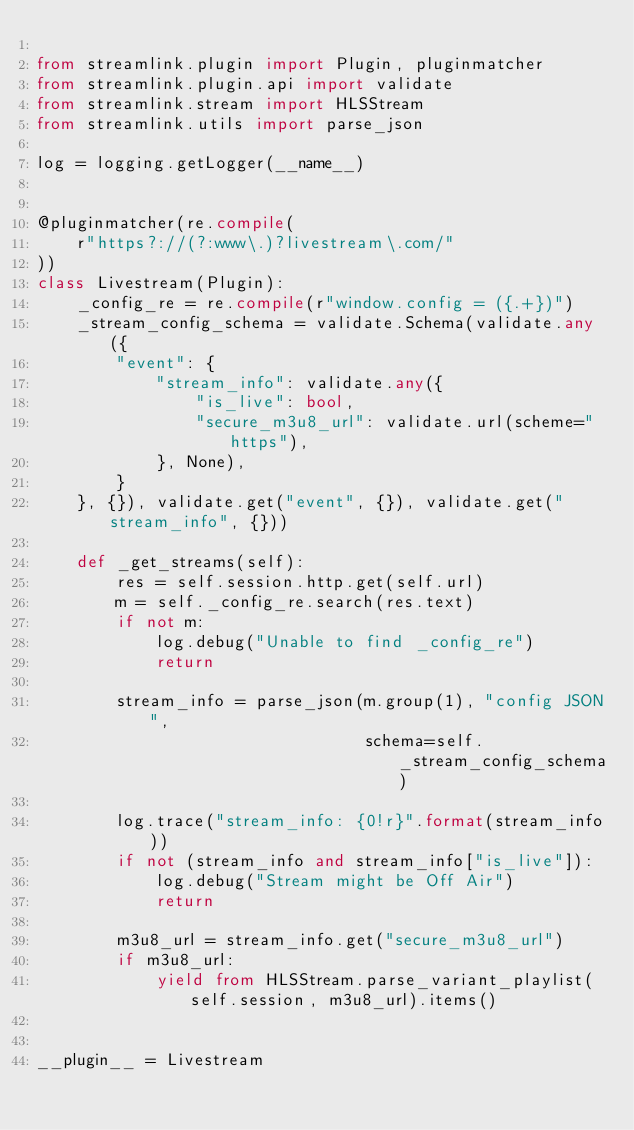Convert code to text. <code><loc_0><loc_0><loc_500><loc_500><_Python_>
from streamlink.plugin import Plugin, pluginmatcher
from streamlink.plugin.api import validate
from streamlink.stream import HLSStream
from streamlink.utils import parse_json

log = logging.getLogger(__name__)


@pluginmatcher(re.compile(
    r"https?://(?:www\.)?livestream\.com/"
))
class Livestream(Plugin):
    _config_re = re.compile(r"window.config = ({.+})")
    _stream_config_schema = validate.Schema(validate.any({
        "event": {
            "stream_info": validate.any({
                "is_live": bool,
                "secure_m3u8_url": validate.url(scheme="https"),
            }, None),
        }
    }, {}), validate.get("event", {}), validate.get("stream_info", {}))

    def _get_streams(self):
        res = self.session.http.get(self.url)
        m = self._config_re.search(res.text)
        if not m:
            log.debug("Unable to find _config_re")
            return

        stream_info = parse_json(m.group(1), "config JSON",
                                 schema=self._stream_config_schema)

        log.trace("stream_info: {0!r}".format(stream_info))
        if not (stream_info and stream_info["is_live"]):
            log.debug("Stream might be Off Air")
            return

        m3u8_url = stream_info.get("secure_m3u8_url")
        if m3u8_url:
            yield from HLSStream.parse_variant_playlist(self.session, m3u8_url).items()


__plugin__ = Livestream
</code> 